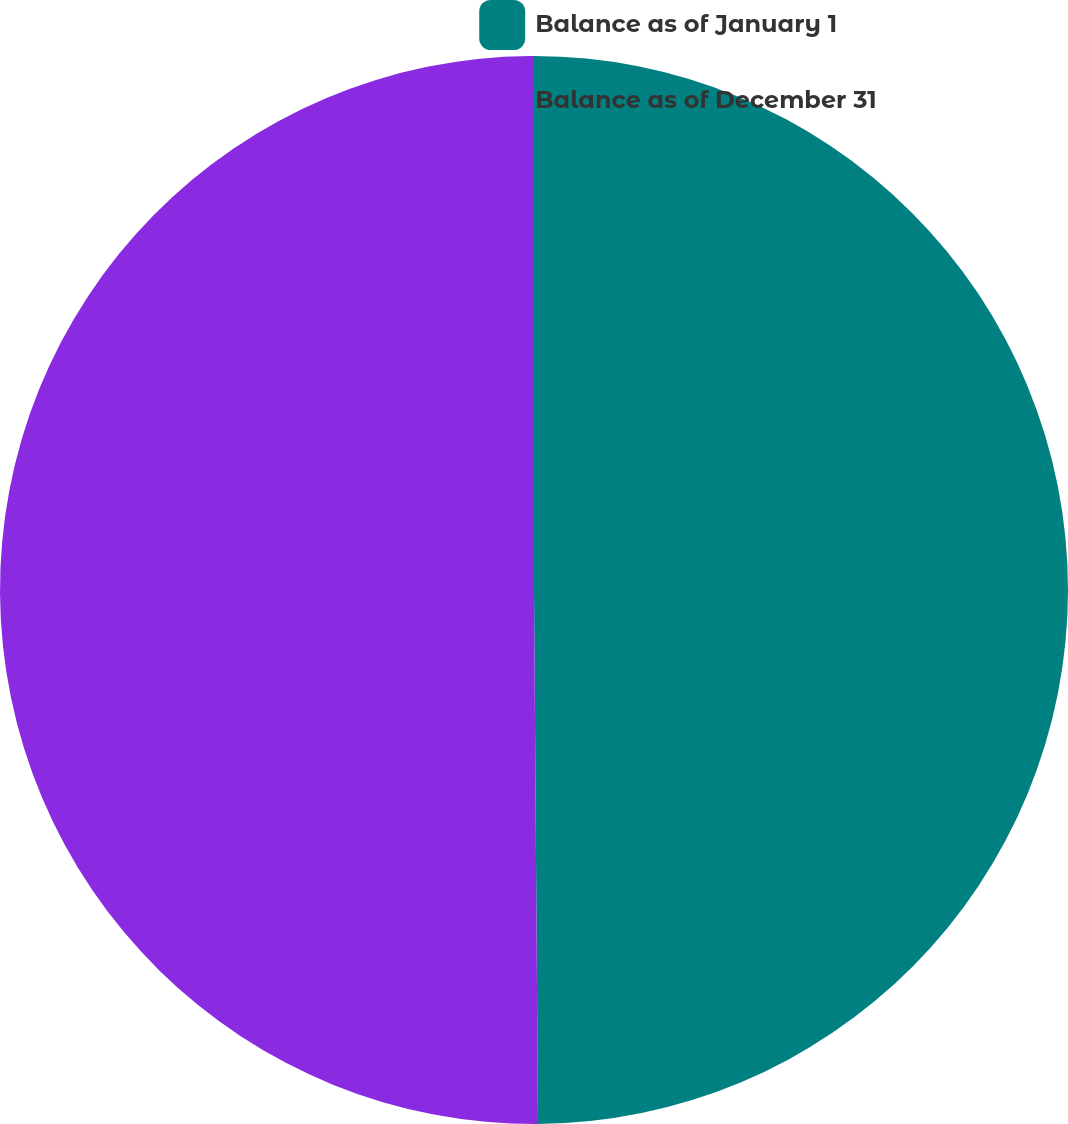Convert chart to OTSL. <chart><loc_0><loc_0><loc_500><loc_500><pie_chart><fcel>Balance as of January 1<fcel>Balance as of December 31<nl><fcel>49.88%<fcel>50.12%<nl></chart> 